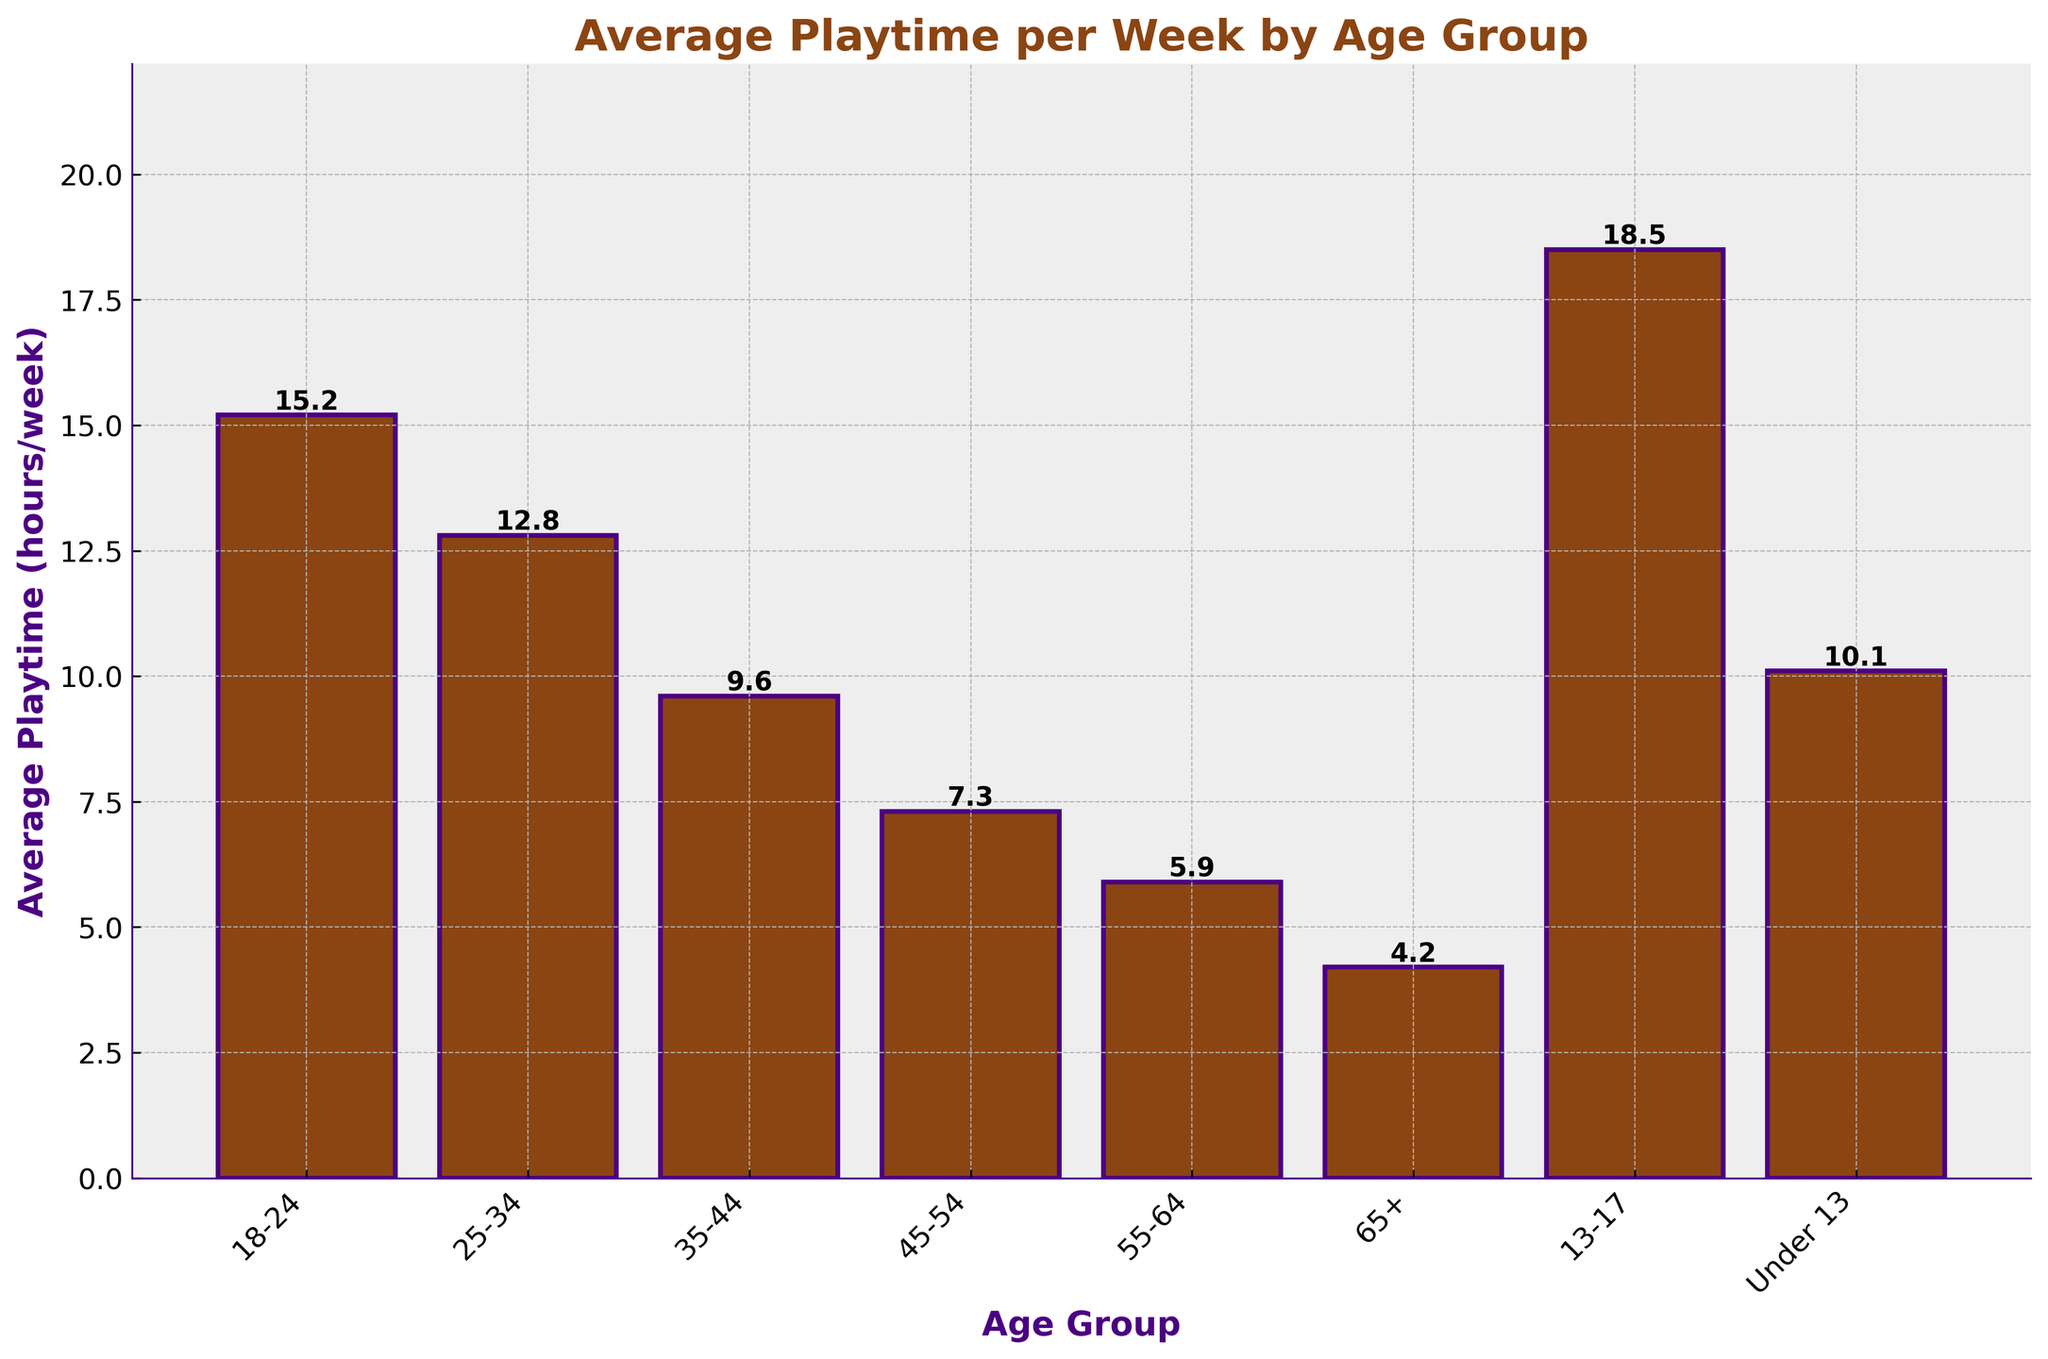What is the average playtime for the age group 18-24? The bar chart shows the average playtime per week for different age groups. Looking at the bar for the age group 18-24, the height indicates the value 15.2 hours per week.
Answer: 15.2 hours/week Which age group has the lowest average playtime? The bar chart displays the average playtime for various age groups. The shortest bar corresponds to the 65+ age group, indicating the least playtime.
Answer: 65+ How much more time do gamers aged 13-17 spend playing compared to those aged 45-54? From the chart, the 13-17 age group plays 18.5 hours per week, while the 45-54 age group plays 7.3 hours per week. The difference is 18.5 - 7.3 = 11.2 hours.
Answer: 11.2 hours Which age group has a higher average playtime: 25-34 or 35-44? The bar chart shows that the 25-34 age group has an average playtime of 12.8 hours per week, while the 35-44 age group has 9.6 hours per week. Comparing these, 12.8 is greater than 9.6.
Answer: 25-34 What is the total combined playtime for the age groups 18-24, 25-34, and 35-44? According to the chart, the average playtime is 15.2 hours for 18-24, 12.8 hours for 25-34, and 9.6 hours for 35-44. Summing these values gives 15.2 + 12.8 + 9.6 = 37.6 hours.
Answer: 37.6 hours Which age group's bar is the tallest on the chart? Observing the chart, the tallest bar belongs to the 13-17 age group.
Answer: 13-17 By how much does the playtime of gamers aged under 13 exceed that of the 55-64 age group? The playtime for the under 13 age group is 10.1 hours per week, while for the 55-64 age group, it is 5.9 hours per week. The difference is 10.1 - 5.9 = 4.2 hours.
Answer: 4.2 hours Which two age groups have an average playtime less than 6 hours per week? The bars for the 55-64 (5.9 hours) and 65+ (4.2 hours) age groups are the only ones below the 6-hour mark in the chart.
Answer: 55-64, 65+ What is the average playtime for age groups over 35 years old? The age groups over 35 are 35-44 (9.6 hours), 45-54 (7.3 hours), 55-64 (5.9 hours), and 65+ (4.2 hours). Adding these together and dividing by 4 gives (9.6 + 7.3 + 5.9 + 4.2)/4 = 6.75 hours.
Answer: 6.75 hours 